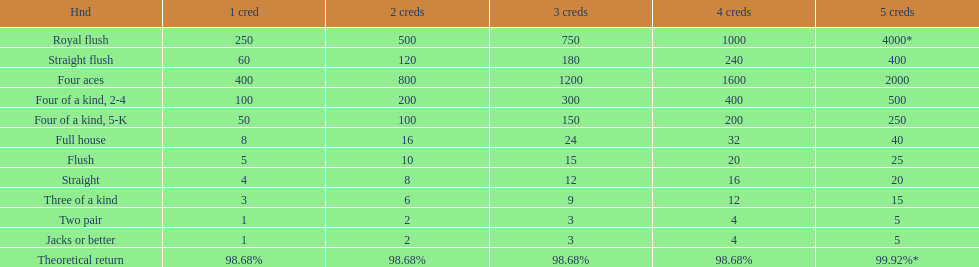Which is a higher standing hand: a straight or a flush? Flush. 